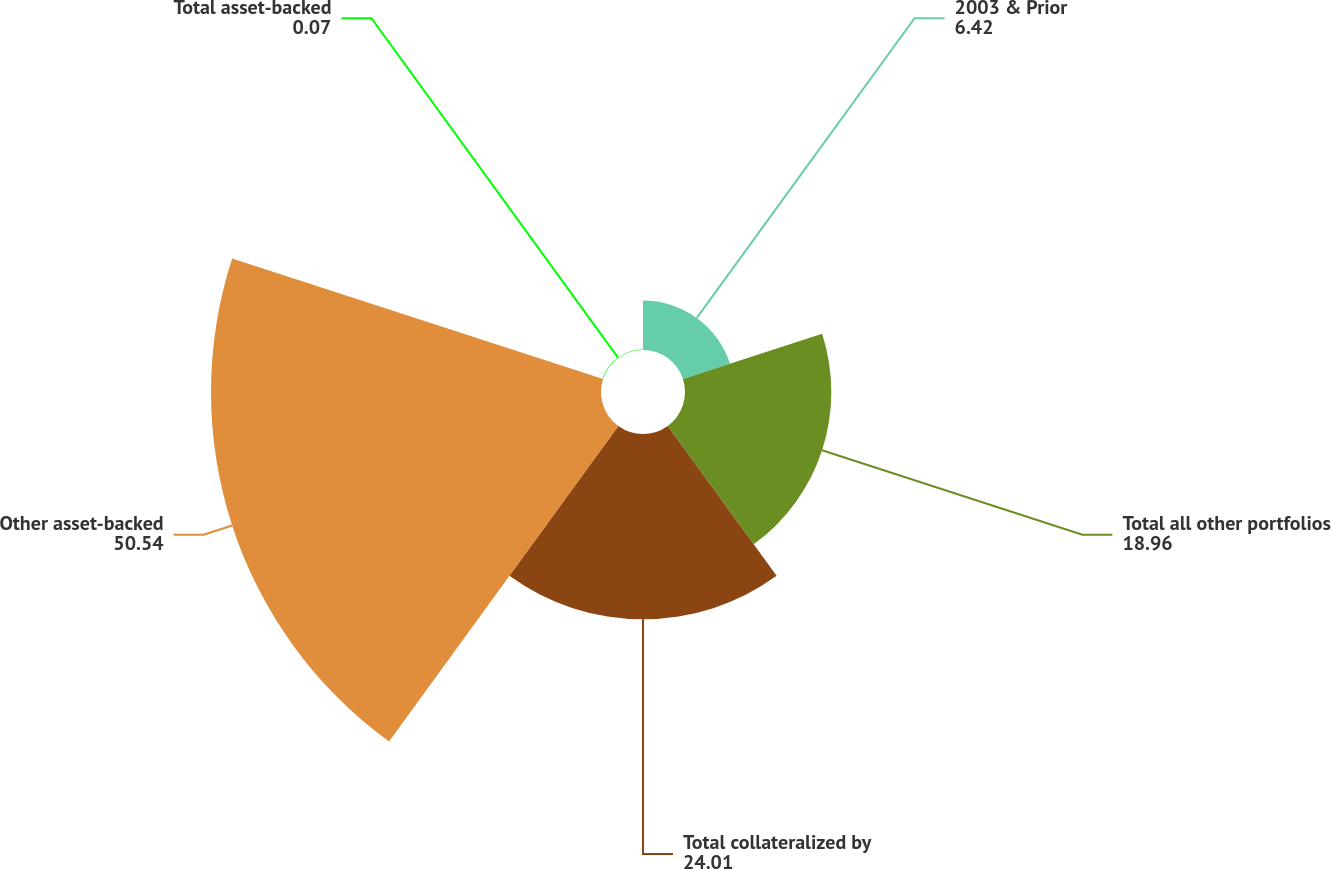Convert chart. <chart><loc_0><loc_0><loc_500><loc_500><pie_chart><fcel>2003 & Prior<fcel>Total all other portfolios<fcel>Total collateralized by<fcel>Other asset-backed<fcel>Total asset-backed<nl><fcel>6.42%<fcel>18.96%<fcel>24.01%<fcel>50.54%<fcel>0.07%<nl></chart> 